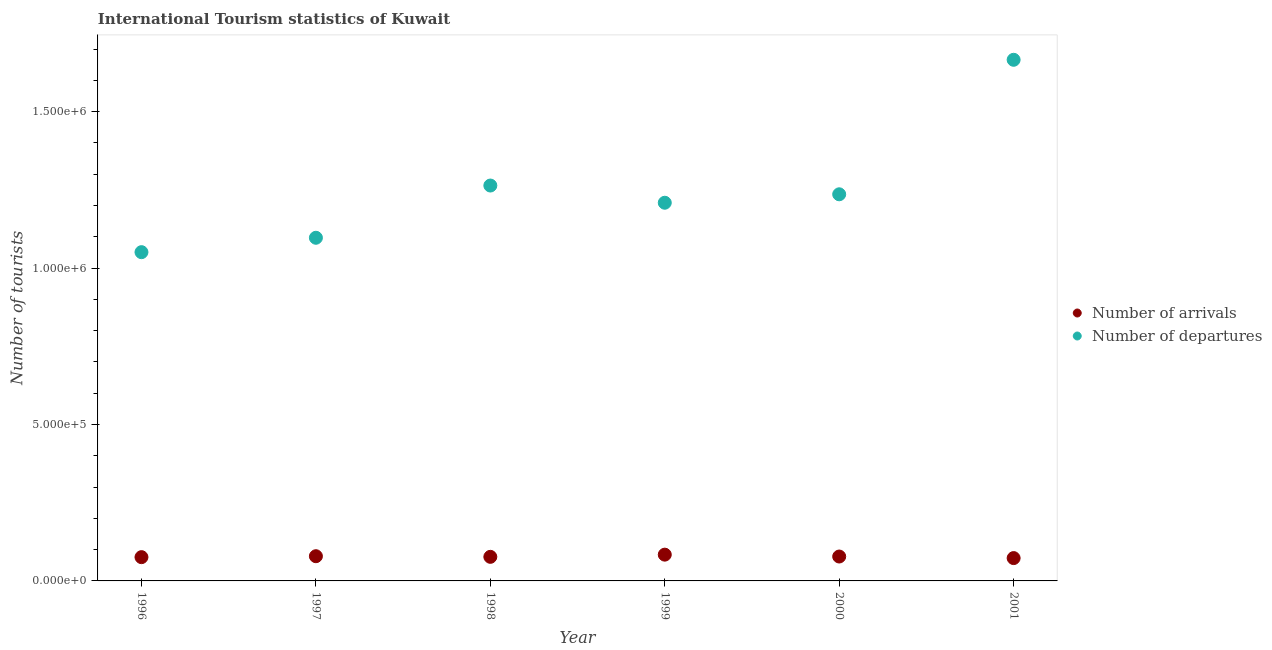What is the number of tourist arrivals in 2001?
Give a very brief answer. 7.30e+04. Across all years, what is the maximum number of tourist arrivals?
Your response must be concise. 8.40e+04. Across all years, what is the minimum number of tourist arrivals?
Your response must be concise. 7.30e+04. In which year was the number of tourist arrivals minimum?
Offer a terse response. 2001. What is the total number of tourist arrivals in the graph?
Keep it short and to the point. 4.67e+05. What is the difference between the number of tourist departures in 1998 and that in 2000?
Provide a short and direct response. 2.80e+04. What is the difference between the number of tourist departures in 2001 and the number of tourist arrivals in 1999?
Ensure brevity in your answer.  1.58e+06. What is the average number of tourist departures per year?
Keep it short and to the point. 1.25e+06. In the year 1998, what is the difference between the number of tourist arrivals and number of tourist departures?
Provide a short and direct response. -1.19e+06. In how many years, is the number of tourist arrivals greater than 900000?
Offer a terse response. 0. What is the ratio of the number of tourist departures in 1997 to that in 2000?
Keep it short and to the point. 0.89. Is the number of tourist arrivals in 1999 less than that in 2001?
Your response must be concise. No. What is the difference between the highest and the second highest number of tourist departures?
Provide a succinct answer. 4.02e+05. What is the difference between the highest and the lowest number of tourist departures?
Give a very brief answer. 6.15e+05. In how many years, is the number of tourist departures greater than the average number of tourist departures taken over all years?
Provide a succinct answer. 2. Is the number of tourist arrivals strictly less than the number of tourist departures over the years?
Ensure brevity in your answer.  Yes. How many dotlines are there?
Provide a succinct answer. 2. How many years are there in the graph?
Ensure brevity in your answer.  6. Are the values on the major ticks of Y-axis written in scientific E-notation?
Offer a very short reply. Yes. Does the graph contain any zero values?
Offer a very short reply. No. Does the graph contain grids?
Offer a terse response. No. How many legend labels are there?
Your response must be concise. 2. What is the title of the graph?
Keep it short and to the point. International Tourism statistics of Kuwait. What is the label or title of the X-axis?
Offer a very short reply. Year. What is the label or title of the Y-axis?
Offer a terse response. Number of tourists. What is the Number of tourists in Number of arrivals in 1996?
Provide a short and direct response. 7.60e+04. What is the Number of tourists of Number of departures in 1996?
Make the answer very short. 1.05e+06. What is the Number of tourists in Number of arrivals in 1997?
Provide a short and direct response. 7.90e+04. What is the Number of tourists in Number of departures in 1997?
Offer a very short reply. 1.10e+06. What is the Number of tourists of Number of arrivals in 1998?
Your answer should be very brief. 7.70e+04. What is the Number of tourists of Number of departures in 1998?
Give a very brief answer. 1.26e+06. What is the Number of tourists of Number of arrivals in 1999?
Your answer should be very brief. 8.40e+04. What is the Number of tourists of Number of departures in 1999?
Make the answer very short. 1.21e+06. What is the Number of tourists in Number of arrivals in 2000?
Provide a short and direct response. 7.80e+04. What is the Number of tourists in Number of departures in 2000?
Ensure brevity in your answer.  1.24e+06. What is the Number of tourists of Number of arrivals in 2001?
Your response must be concise. 7.30e+04. What is the Number of tourists of Number of departures in 2001?
Make the answer very short. 1.67e+06. Across all years, what is the maximum Number of tourists in Number of arrivals?
Provide a short and direct response. 8.40e+04. Across all years, what is the maximum Number of tourists of Number of departures?
Ensure brevity in your answer.  1.67e+06. Across all years, what is the minimum Number of tourists of Number of arrivals?
Ensure brevity in your answer.  7.30e+04. Across all years, what is the minimum Number of tourists in Number of departures?
Ensure brevity in your answer.  1.05e+06. What is the total Number of tourists in Number of arrivals in the graph?
Your response must be concise. 4.67e+05. What is the total Number of tourists of Number of departures in the graph?
Your answer should be compact. 7.52e+06. What is the difference between the Number of tourists in Number of arrivals in 1996 and that in 1997?
Give a very brief answer. -3000. What is the difference between the Number of tourists of Number of departures in 1996 and that in 1997?
Your response must be concise. -4.60e+04. What is the difference between the Number of tourists of Number of arrivals in 1996 and that in 1998?
Provide a short and direct response. -1000. What is the difference between the Number of tourists in Number of departures in 1996 and that in 1998?
Provide a short and direct response. -2.13e+05. What is the difference between the Number of tourists of Number of arrivals in 1996 and that in 1999?
Provide a short and direct response. -8000. What is the difference between the Number of tourists of Number of departures in 1996 and that in 1999?
Ensure brevity in your answer.  -1.58e+05. What is the difference between the Number of tourists of Number of arrivals in 1996 and that in 2000?
Ensure brevity in your answer.  -2000. What is the difference between the Number of tourists of Number of departures in 1996 and that in 2000?
Offer a terse response. -1.85e+05. What is the difference between the Number of tourists in Number of arrivals in 1996 and that in 2001?
Ensure brevity in your answer.  3000. What is the difference between the Number of tourists in Number of departures in 1996 and that in 2001?
Make the answer very short. -6.15e+05. What is the difference between the Number of tourists of Number of departures in 1997 and that in 1998?
Offer a terse response. -1.67e+05. What is the difference between the Number of tourists in Number of arrivals in 1997 and that in 1999?
Your answer should be very brief. -5000. What is the difference between the Number of tourists in Number of departures in 1997 and that in 1999?
Provide a succinct answer. -1.12e+05. What is the difference between the Number of tourists of Number of departures in 1997 and that in 2000?
Your answer should be compact. -1.39e+05. What is the difference between the Number of tourists of Number of arrivals in 1997 and that in 2001?
Your response must be concise. 6000. What is the difference between the Number of tourists in Number of departures in 1997 and that in 2001?
Keep it short and to the point. -5.69e+05. What is the difference between the Number of tourists of Number of arrivals in 1998 and that in 1999?
Give a very brief answer. -7000. What is the difference between the Number of tourists of Number of departures in 1998 and that in 1999?
Ensure brevity in your answer.  5.50e+04. What is the difference between the Number of tourists in Number of arrivals in 1998 and that in 2000?
Your answer should be very brief. -1000. What is the difference between the Number of tourists of Number of departures in 1998 and that in 2000?
Offer a terse response. 2.80e+04. What is the difference between the Number of tourists of Number of arrivals in 1998 and that in 2001?
Provide a succinct answer. 4000. What is the difference between the Number of tourists in Number of departures in 1998 and that in 2001?
Offer a very short reply. -4.02e+05. What is the difference between the Number of tourists in Number of arrivals in 1999 and that in 2000?
Keep it short and to the point. 6000. What is the difference between the Number of tourists in Number of departures in 1999 and that in 2000?
Provide a succinct answer. -2.70e+04. What is the difference between the Number of tourists in Number of arrivals in 1999 and that in 2001?
Your response must be concise. 1.10e+04. What is the difference between the Number of tourists in Number of departures in 1999 and that in 2001?
Provide a succinct answer. -4.57e+05. What is the difference between the Number of tourists in Number of departures in 2000 and that in 2001?
Give a very brief answer. -4.30e+05. What is the difference between the Number of tourists in Number of arrivals in 1996 and the Number of tourists in Number of departures in 1997?
Make the answer very short. -1.02e+06. What is the difference between the Number of tourists in Number of arrivals in 1996 and the Number of tourists in Number of departures in 1998?
Offer a very short reply. -1.19e+06. What is the difference between the Number of tourists of Number of arrivals in 1996 and the Number of tourists of Number of departures in 1999?
Your response must be concise. -1.13e+06. What is the difference between the Number of tourists in Number of arrivals in 1996 and the Number of tourists in Number of departures in 2000?
Keep it short and to the point. -1.16e+06. What is the difference between the Number of tourists in Number of arrivals in 1996 and the Number of tourists in Number of departures in 2001?
Offer a very short reply. -1.59e+06. What is the difference between the Number of tourists of Number of arrivals in 1997 and the Number of tourists of Number of departures in 1998?
Offer a very short reply. -1.18e+06. What is the difference between the Number of tourists of Number of arrivals in 1997 and the Number of tourists of Number of departures in 1999?
Your response must be concise. -1.13e+06. What is the difference between the Number of tourists in Number of arrivals in 1997 and the Number of tourists in Number of departures in 2000?
Offer a terse response. -1.16e+06. What is the difference between the Number of tourists of Number of arrivals in 1997 and the Number of tourists of Number of departures in 2001?
Give a very brief answer. -1.59e+06. What is the difference between the Number of tourists of Number of arrivals in 1998 and the Number of tourists of Number of departures in 1999?
Offer a very short reply. -1.13e+06. What is the difference between the Number of tourists in Number of arrivals in 1998 and the Number of tourists in Number of departures in 2000?
Ensure brevity in your answer.  -1.16e+06. What is the difference between the Number of tourists of Number of arrivals in 1998 and the Number of tourists of Number of departures in 2001?
Offer a terse response. -1.59e+06. What is the difference between the Number of tourists in Number of arrivals in 1999 and the Number of tourists in Number of departures in 2000?
Give a very brief answer. -1.15e+06. What is the difference between the Number of tourists in Number of arrivals in 1999 and the Number of tourists in Number of departures in 2001?
Your answer should be compact. -1.58e+06. What is the difference between the Number of tourists in Number of arrivals in 2000 and the Number of tourists in Number of departures in 2001?
Provide a succinct answer. -1.59e+06. What is the average Number of tourists in Number of arrivals per year?
Your answer should be compact. 7.78e+04. What is the average Number of tourists in Number of departures per year?
Keep it short and to the point. 1.25e+06. In the year 1996, what is the difference between the Number of tourists in Number of arrivals and Number of tourists in Number of departures?
Your answer should be very brief. -9.75e+05. In the year 1997, what is the difference between the Number of tourists in Number of arrivals and Number of tourists in Number of departures?
Provide a succinct answer. -1.02e+06. In the year 1998, what is the difference between the Number of tourists of Number of arrivals and Number of tourists of Number of departures?
Offer a very short reply. -1.19e+06. In the year 1999, what is the difference between the Number of tourists in Number of arrivals and Number of tourists in Number of departures?
Provide a short and direct response. -1.12e+06. In the year 2000, what is the difference between the Number of tourists in Number of arrivals and Number of tourists in Number of departures?
Your answer should be very brief. -1.16e+06. In the year 2001, what is the difference between the Number of tourists of Number of arrivals and Number of tourists of Number of departures?
Ensure brevity in your answer.  -1.59e+06. What is the ratio of the Number of tourists of Number of arrivals in 1996 to that in 1997?
Your response must be concise. 0.96. What is the ratio of the Number of tourists in Number of departures in 1996 to that in 1997?
Provide a short and direct response. 0.96. What is the ratio of the Number of tourists in Number of arrivals in 1996 to that in 1998?
Make the answer very short. 0.99. What is the ratio of the Number of tourists in Number of departures in 1996 to that in 1998?
Provide a short and direct response. 0.83. What is the ratio of the Number of tourists of Number of arrivals in 1996 to that in 1999?
Your response must be concise. 0.9. What is the ratio of the Number of tourists in Number of departures in 1996 to that in 1999?
Give a very brief answer. 0.87. What is the ratio of the Number of tourists in Number of arrivals in 1996 to that in 2000?
Your answer should be very brief. 0.97. What is the ratio of the Number of tourists of Number of departures in 1996 to that in 2000?
Your response must be concise. 0.85. What is the ratio of the Number of tourists in Number of arrivals in 1996 to that in 2001?
Offer a very short reply. 1.04. What is the ratio of the Number of tourists in Number of departures in 1996 to that in 2001?
Offer a terse response. 0.63. What is the ratio of the Number of tourists in Number of arrivals in 1997 to that in 1998?
Offer a very short reply. 1.03. What is the ratio of the Number of tourists of Number of departures in 1997 to that in 1998?
Offer a terse response. 0.87. What is the ratio of the Number of tourists of Number of arrivals in 1997 to that in 1999?
Offer a terse response. 0.94. What is the ratio of the Number of tourists in Number of departures in 1997 to that in 1999?
Ensure brevity in your answer.  0.91. What is the ratio of the Number of tourists of Number of arrivals in 1997 to that in 2000?
Keep it short and to the point. 1.01. What is the ratio of the Number of tourists in Number of departures in 1997 to that in 2000?
Keep it short and to the point. 0.89. What is the ratio of the Number of tourists of Number of arrivals in 1997 to that in 2001?
Ensure brevity in your answer.  1.08. What is the ratio of the Number of tourists in Number of departures in 1997 to that in 2001?
Provide a short and direct response. 0.66. What is the ratio of the Number of tourists of Number of arrivals in 1998 to that in 1999?
Give a very brief answer. 0.92. What is the ratio of the Number of tourists in Number of departures in 1998 to that in 1999?
Offer a terse response. 1.05. What is the ratio of the Number of tourists in Number of arrivals in 1998 to that in 2000?
Provide a succinct answer. 0.99. What is the ratio of the Number of tourists in Number of departures in 1998 to that in 2000?
Offer a very short reply. 1.02. What is the ratio of the Number of tourists of Number of arrivals in 1998 to that in 2001?
Your response must be concise. 1.05. What is the ratio of the Number of tourists in Number of departures in 1998 to that in 2001?
Provide a short and direct response. 0.76. What is the ratio of the Number of tourists of Number of departures in 1999 to that in 2000?
Offer a terse response. 0.98. What is the ratio of the Number of tourists in Number of arrivals in 1999 to that in 2001?
Offer a very short reply. 1.15. What is the ratio of the Number of tourists in Number of departures in 1999 to that in 2001?
Offer a very short reply. 0.73. What is the ratio of the Number of tourists of Number of arrivals in 2000 to that in 2001?
Offer a terse response. 1.07. What is the ratio of the Number of tourists in Number of departures in 2000 to that in 2001?
Make the answer very short. 0.74. What is the difference between the highest and the second highest Number of tourists of Number of arrivals?
Your response must be concise. 5000. What is the difference between the highest and the second highest Number of tourists in Number of departures?
Offer a very short reply. 4.02e+05. What is the difference between the highest and the lowest Number of tourists of Number of arrivals?
Offer a terse response. 1.10e+04. What is the difference between the highest and the lowest Number of tourists of Number of departures?
Give a very brief answer. 6.15e+05. 